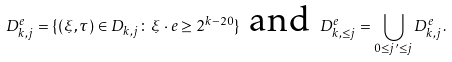Convert formula to latex. <formula><loc_0><loc_0><loc_500><loc_500>D _ { k , j } ^ { e } = \{ ( \xi , \tau ) \in D _ { k , j } \colon \xi \cdot e \geq 2 ^ { k - 2 0 } \} \text { and } D _ { k , \leq j } ^ { e } = \bigcup _ { 0 \leq j ^ { \prime } \leq j } D _ { k , j } ^ { e } .</formula> 